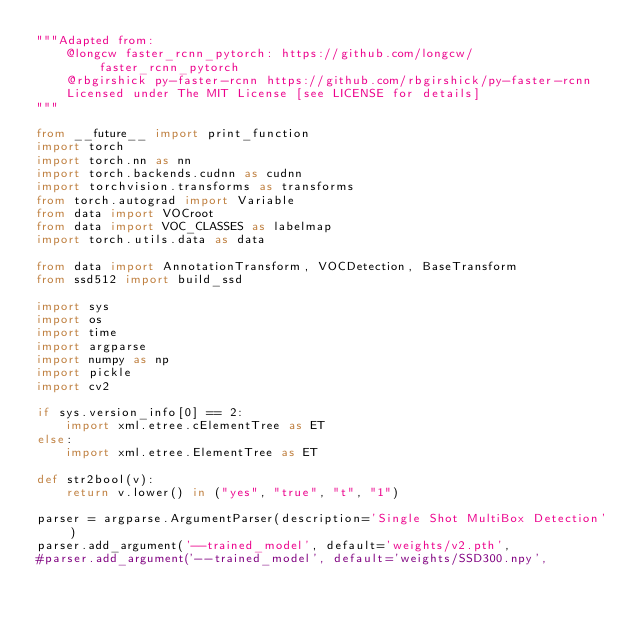Convert code to text. <code><loc_0><loc_0><loc_500><loc_500><_Python_>"""Adapted from:
    @longcw faster_rcnn_pytorch: https://github.com/longcw/faster_rcnn_pytorch
    @rbgirshick py-faster-rcnn https://github.com/rbgirshick/py-faster-rcnn
    Licensed under The MIT License [see LICENSE for details]
"""

from __future__ import print_function
import torch
import torch.nn as nn
import torch.backends.cudnn as cudnn
import torchvision.transforms as transforms
from torch.autograd import Variable
from data import VOCroot
from data import VOC_CLASSES as labelmap
import torch.utils.data as data

from data import AnnotationTransform, VOCDetection, BaseTransform
from ssd512 import build_ssd

import sys
import os
import time
import argparse
import numpy as np
import pickle
import cv2

if sys.version_info[0] == 2:
    import xml.etree.cElementTree as ET
else:
    import xml.etree.ElementTree as ET

def str2bool(v):
    return v.lower() in ("yes", "true", "t", "1")

parser = argparse.ArgumentParser(description='Single Shot MultiBox Detection')
parser.add_argument('--trained_model', default='weights/v2.pth',
#parser.add_argument('--trained_model', default='weights/SSD300.npy',</code> 